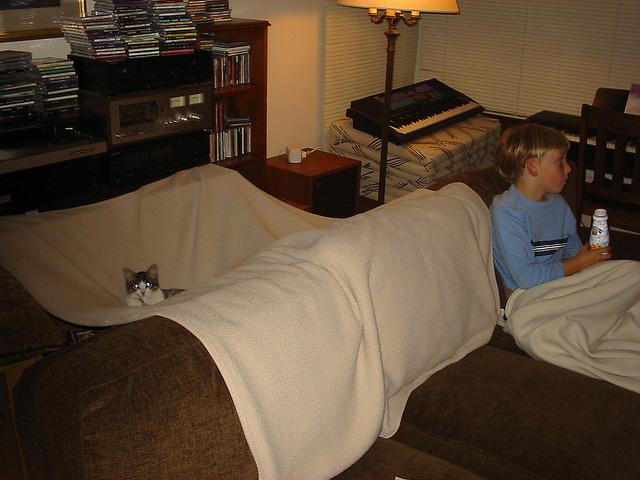Are they at home?
Keep it brief. Yes. Is the person in bed?
Write a very short answer. No. Is the quilt custom made?
Quick response, please. No. What is the cat on?
Short answer required. Blanket. What is the boy drinking?
Write a very short answer. Milk. What is he drinking?
Be succinct. Milk. What is the boy doing?
Write a very short answer. Sitting. What animal is laying on the floor?
Be succinct. Cat. Why is the cat on the bed?
Quick response, please. It is comfortable. How many kids are there?
Write a very short answer. 1. What is in the back corner by both windows?
Write a very short answer. Keyboard. What kind of animal is standing next to the person?
Write a very short answer. Cat. How many dogs are there?
Answer briefly. 0. How many kids are in the picture?
Answer briefly. 1. What is on the shelf?
Short answer required. Cds. 